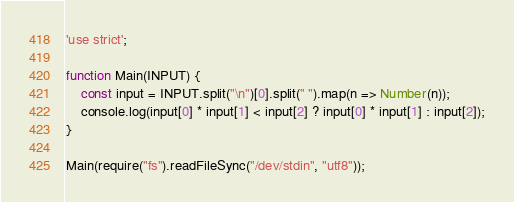Convert code to text. <code><loc_0><loc_0><loc_500><loc_500><_JavaScript_>'use strict';

function Main(INPUT) {
    const input = INPUT.split("\n")[0].split(" ").map(n => Number(n));
    console.log(input[0] * input[1] < input[2] ? input[0] * input[1] : input[2]);
}

Main(require("fs").readFileSync("/dev/stdin", "utf8"));
</code> 